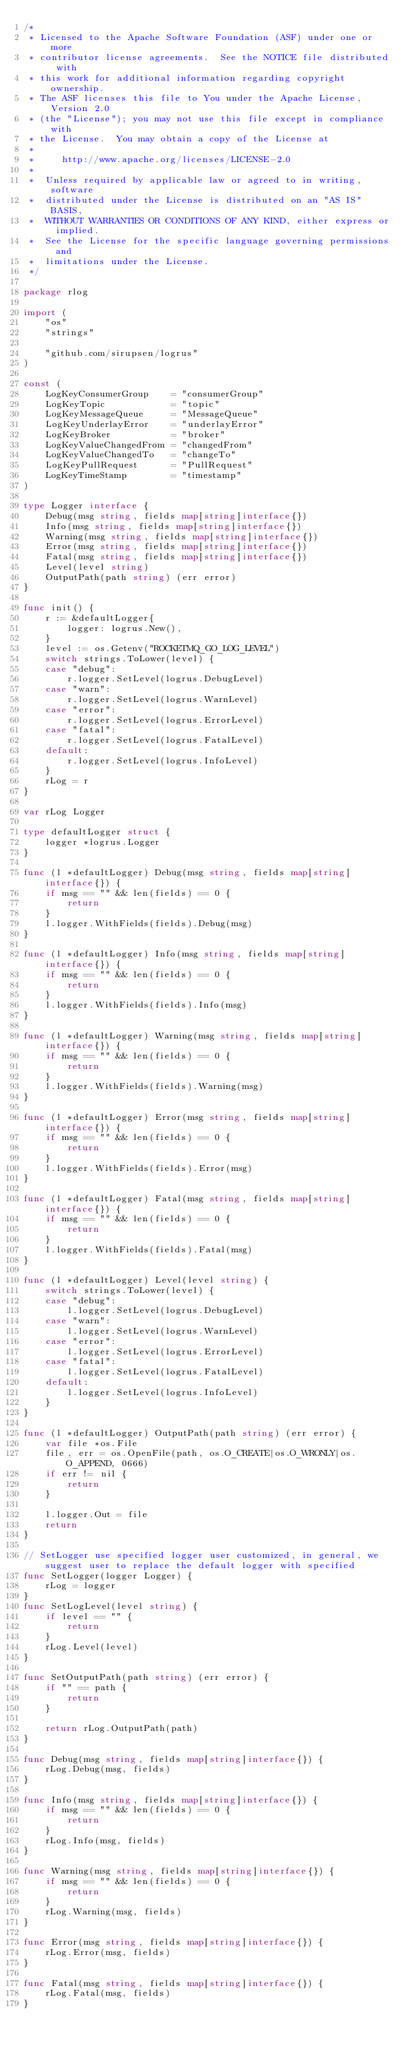Convert code to text. <code><loc_0><loc_0><loc_500><loc_500><_Go_>/*
 * Licensed to the Apache Software Foundation (ASF) under one or more
 * contributor license agreements.  See the NOTICE file distributed with
 * this work for additional information regarding copyright ownership.
 * The ASF licenses this file to You under the Apache License, Version 2.0
 * (the "License"); you may not use this file except in compliance with
 * the License.  You may obtain a copy of the License at
 *
 *     http://www.apache.org/licenses/LICENSE-2.0
 *
 *  Unless required by applicable law or agreed to in writing, software
 *  distributed under the License is distributed on an "AS IS" BASIS,
 *  WITHOUT WARRANTIES OR CONDITIONS OF ANY KIND, either express or implied.
 *  See the License for the specific language governing permissions and
 *  limitations under the License.
 */

package rlog

import (
	"os"
	"strings"

	"github.com/sirupsen/logrus"
)

const (
	LogKeyConsumerGroup    = "consumerGroup"
	LogKeyTopic            = "topic"
	LogKeyMessageQueue     = "MessageQueue"
	LogKeyUnderlayError    = "underlayError"
	LogKeyBroker           = "broker"
	LogKeyValueChangedFrom = "changedFrom"
	LogKeyValueChangedTo   = "changeTo"
	LogKeyPullRequest      = "PullRequest"
	LogKeyTimeStamp        = "timestamp"
)

type Logger interface {
	Debug(msg string, fields map[string]interface{})
	Info(msg string, fields map[string]interface{})
	Warning(msg string, fields map[string]interface{})
	Error(msg string, fields map[string]interface{})
	Fatal(msg string, fields map[string]interface{})
	Level(level string)
	OutputPath(path string) (err error)
}

func init() {
	r := &defaultLogger{
		logger: logrus.New(),
	}
	level := os.Getenv("ROCKETMQ_GO_LOG_LEVEL")
	switch strings.ToLower(level) {
	case "debug":
		r.logger.SetLevel(logrus.DebugLevel)
	case "warn":
		r.logger.SetLevel(logrus.WarnLevel)
	case "error":
		r.logger.SetLevel(logrus.ErrorLevel)
	case "fatal":
		r.logger.SetLevel(logrus.FatalLevel)
	default:
		r.logger.SetLevel(logrus.InfoLevel)
	}
	rLog = r
}

var rLog Logger

type defaultLogger struct {
	logger *logrus.Logger
}

func (l *defaultLogger) Debug(msg string, fields map[string]interface{}) {
	if msg == "" && len(fields) == 0 {
		return
	}
	l.logger.WithFields(fields).Debug(msg)
}

func (l *defaultLogger) Info(msg string, fields map[string]interface{}) {
	if msg == "" && len(fields) == 0 {
		return
	}
	l.logger.WithFields(fields).Info(msg)
}

func (l *defaultLogger) Warning(msg string, fields map[string]interface{}) {
	if msg == "" && len(fields) == 0 {
		return
	}
	l.logger.WithFields(fields).Warning(msg)
}

func (l *defaultLogger) Error(msg string, fields map[string]interface{}) {
	if msg == "" && len(fields) == 0 {
		return
	}
	l.logger.WithFields(fields).Error(msg)
}

func (l *defaultLogger) Fatal(msg string, fields map[string]interface{}) {
	if msg == "" && len(fields) == 0 {
		return
	}
	l.logger.WithFields(fields).Fatal(msg)
}

func (l *defaultLogger) Level(level string) {
	switch strings.ToLower(level) {
	case "debug":
		l.logger.SetLevel(logrus.DebugLevel)
	case "warn":
		l.logger.SetLevel(logrus.WarnLevel)
	case "error":
		l.logger.SetLevel(logrus.ErrorLevel)
	case "fatal":
		l.logger.SetLevel(logrus.FatalLevel)
	default:
		l.logger.SetLevel(logrus.InfoLevel)
	}
}

func (l *defaultLogger) OutputPath(path string) (err error) {
	var file *os.File
	file, err = os.OpenFile(path, os.O_CREATE|os.O_WRONLY|os.O_APPEND, 0666)
	if err != nil {
		return
	}

	l.logger.Out = file
	return
}

// SetLogger use specified logger user customized, in general, we suggest user to replace the default logger with specified
func SetLogger(logger Logger) {
	rLog = logger
}
func SetLogLevel(level string) {
	if level == "" {
		return
	}
	rLog.Level(level)
}

func SetOutputPath(path string) (err error) {
	if "" == path {
		return
	}

	return rLog.OutputPath(path)
}

func Debug(msg string, fields map[string]interface{}) {
	rLog.Debug(msg, fields)
}

func Info(msg string, fields map[string]interface{}) {
	if msg == "" && len(fields) == 0 {
		return
	}
	rLog.Info(msg, fields)
}

func Warning(msg string, fields map[string]interface{}) {
	if msg == "" && len(fields) == 0 {
		return
	}
	rLog.Warning(msg, fields)
}

func Error(msg string, fields map[string]interface{}) {
	rLog.Error(msg, fields)
}

func Fatal(msg string, fields map[string]interface{}) {
	rLog.Fatal(msg, fields)
}
</code> 